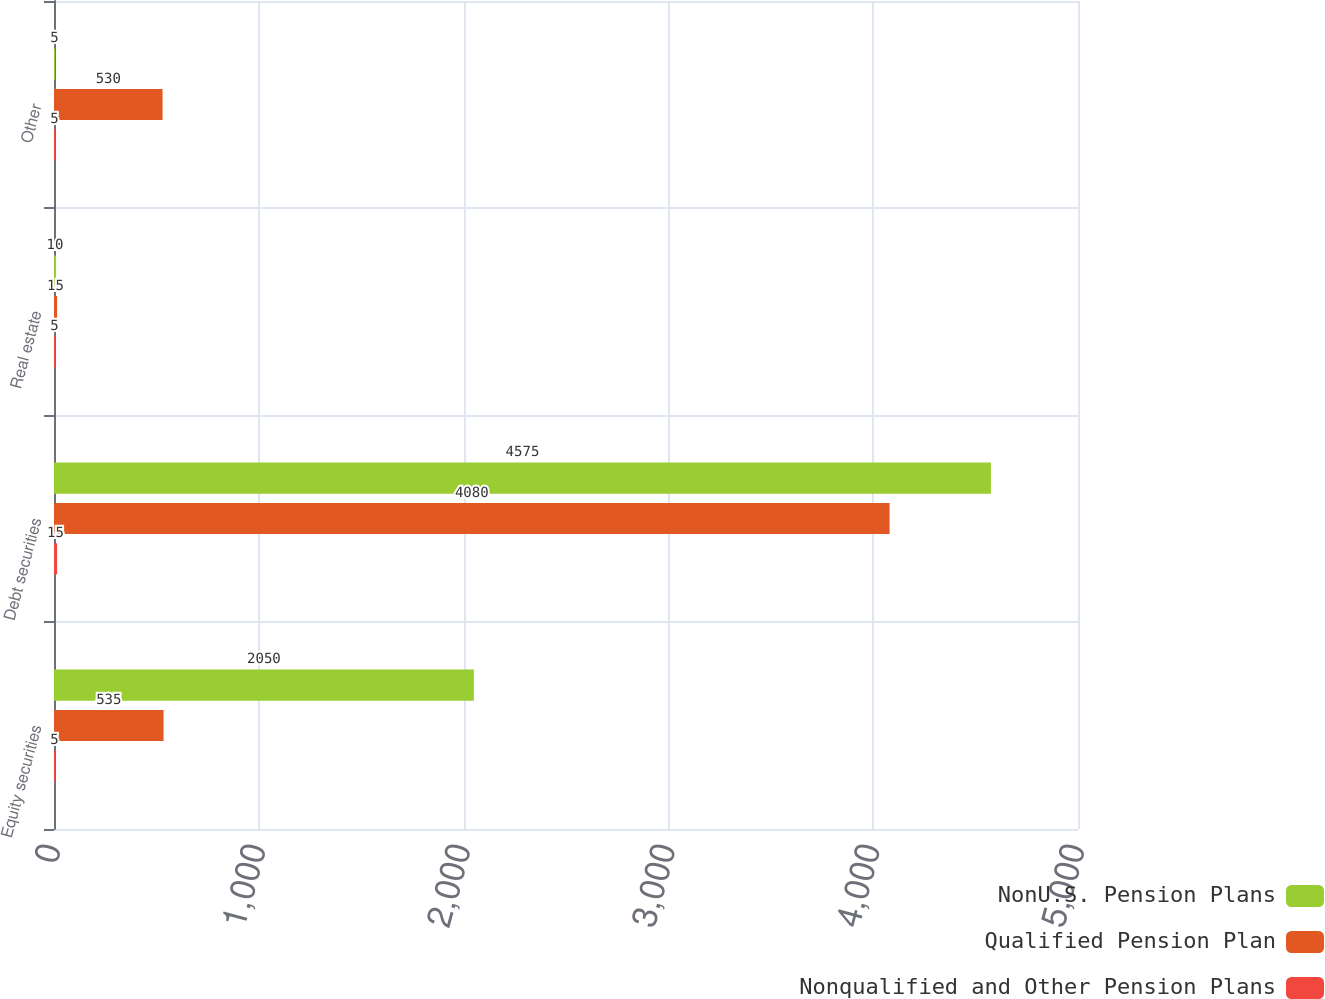Convert chart. <chart><loc_0><loc_0><loc_500><loc_500><stacked_bar_chart><ecel><fcel>Equity securities<fcel>Debt securities<fcel>Real estate<fcel>Other<nl><fcel>NonU.S. Pension Plans<fcel>2050<fcel>4575<fcel>10<fcel>5<nl><fcel>Qualified Pension Plan<fcel>535<fcel>4080<fcel>15<fcel>530<nl><fcel>Nonqualified and Other Pension Plans<fcel>5<fcel>15<fcel>5<fcel>5<nl></chart> 